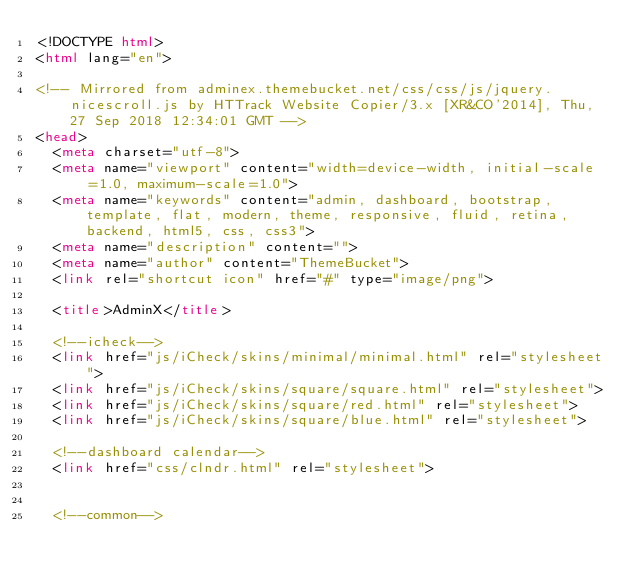<code> <loc_0><loc_0><loc_500><loc_500><_HTML_><!DOCTYPE html>
<html lang="en">

<!-- Mirrored from adminex.themebucket.net/css/css/js/jquery.nicescroll.js by HTTrack Website Copier/3.x [XR&CO'2014], Thu, 27 Sep 2018 12:34:01 GMT -->
<head>
  <meta charset="utf-8">
  <meta name="viewport" content="width=device-width, initial-scale=1.0, maximum-scale=1.0">
  <meta name="keywords" content="admin, dashboard, bootstrap, template, flat, modern, theme, responsive, fluid, retina, backend, html5, css, css3">
  <meta name="description" content="">
  <meta name="author" content="ThemeBucket">
  <link rel="shortcut icon" href="#" type="image/png">

  <title>AdminX</title>

  <!--icheck-->
  <link href="js/iCheck/skins/minimal/minimal.html" rel="stylesheet">
  <link href="js/iCheck/skins/square/square.html" rel="stylesheet">
  <link href="js/iCheck/skins/square/red.html" rel="stylesheet">
  <link href="js/iCheck/skins/square/blue.html" rel="stylesheet">

  <!--dashboard calendar-->
  <link href="css/clndr.html" rel="stylesheet">


  <!--common--></code> 